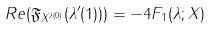<formula> <loc_0><loc_0><loc_500><loc_500>R e ( \mathfrak { F } _ { X ^ { \lambda ( 0 ) } } ( \lambda ^ { \prime } ( 1 ) ) ) = - 4 F _ { 1 } ( \lambda ; X )</formula> 